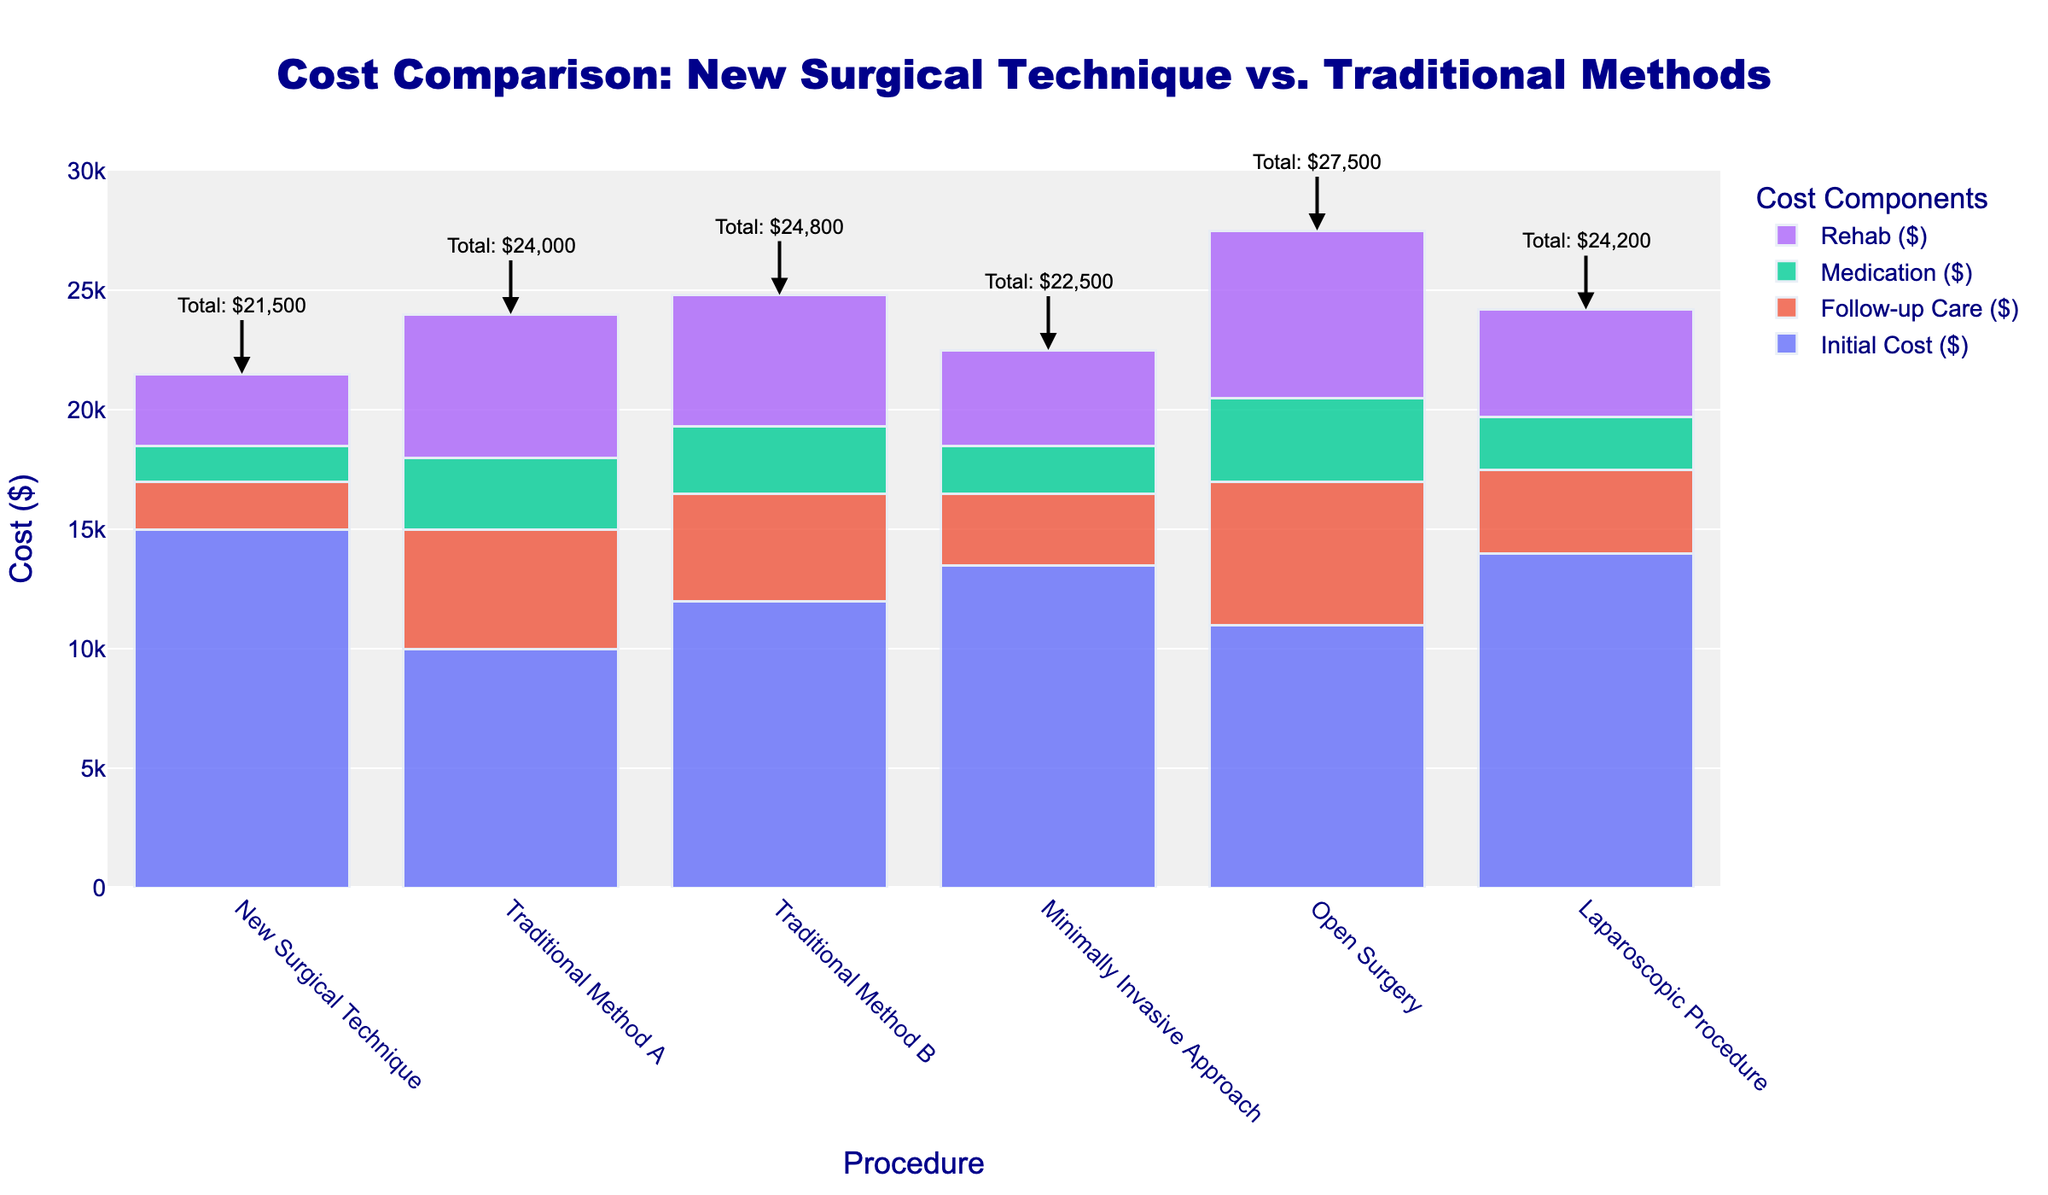Which procedure has the highest total 5-year cost? By looking at the top-most annotations, we see that the Open Surgery has the highest annotation value, $27,500.
Answer: Open Surgery Which has a lower total 5-year cost, New Surgical Technique or Laparoscopic Procedure? New Surgical Technique is annotated with $21,500, and Laparoscopic Procedure with $24,200. Thus, New Surgical Technique has a lower cost.
Answer: New Surgical Technique What is the difference in Initial Cost between the New Surgical Technique and Traditional Method A? Initial Cost for New Surgical Technique is $15,000, and for Traditional Method A is $10,000. The difference is $15,000 - $10,000 = $5,000.
Answer: $5,000 Which procedure has the highest cost for Follow-up Care? By analyzing the heights of the Follow-up Care bars (colored differently) in the chart, Open Surgery's bar is the highest at $6,000.
Answer: Open Surgery How much more does the Open Surgery total 5-year cost exceed that of the New Surgical Technique? Open Surgery's total is $27,500, and New Surgical Technique's total is $21,500. The difference is $27,500 - $21,500 = $6,000.
Answer: $6,000 If we sum the Initial Cost of New Surgical Technique and Follow-up Care of Minimally Invasive Approach, what is the total? Initial Cost for New Surgical Technique: $15,000. Follow-up Care for Minimally Invasive Approach: $3,000. Total sum: $15,000 + $3,000 = $18,000.
Answer: $18,000 What is the average Initial Cost of all procedures? Sum of Initial Costs: $15,000 + $10,000 + $12,000 + $13,500 + $11,000 + $14,000 = $75,500. Number of procedures: 6. Average: $75,500 / 6 = $12,583.33.
Answer: $12,583.33 